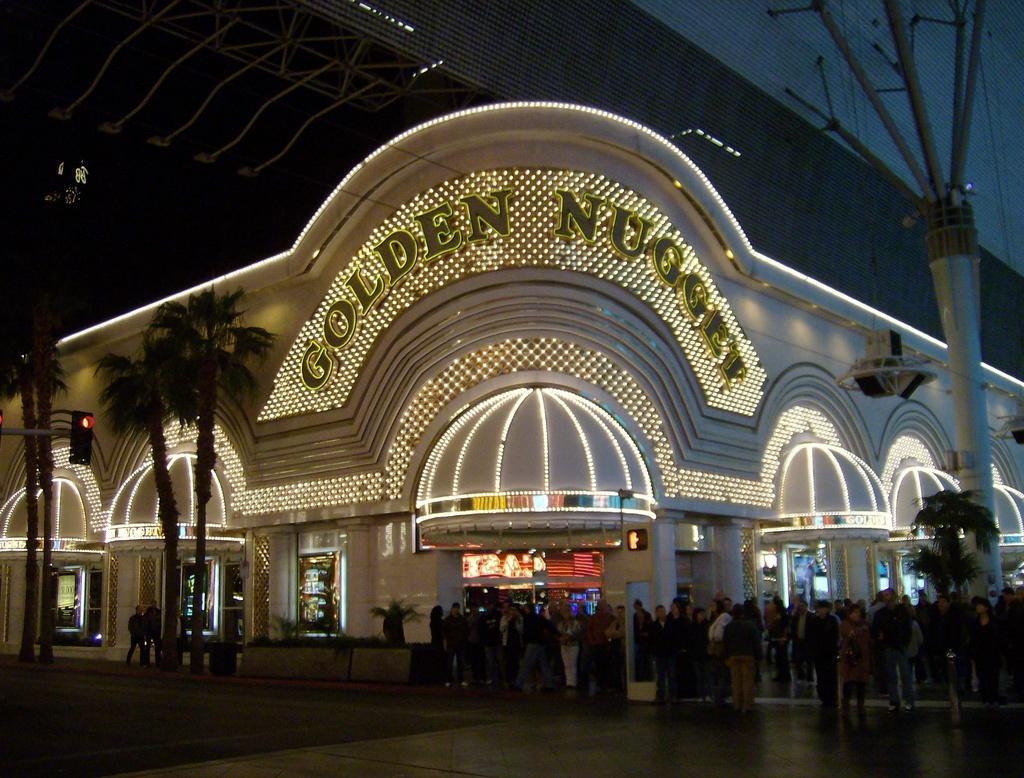Can you describe this image briefly? We can see group of people and trees and we can see building with lights. 